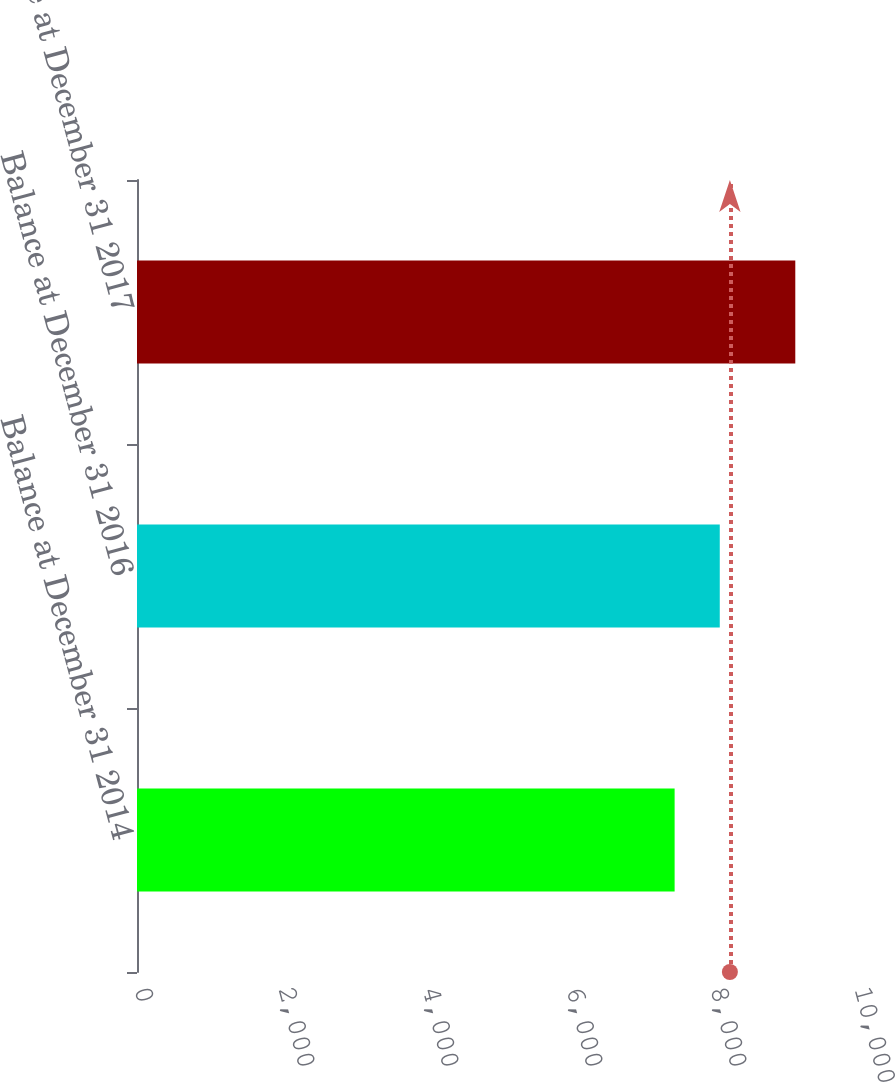Convert chart. <chart><loc_0><loc_0><loc_500><loc_500><bar_chart><fcel>Balance at December 31 2014<fcel>Balance at December 31 2016<fcel>Balance at December 31 2017<nl><fcel>7467<fcel>8094<fcel>9143<nl></chart> 